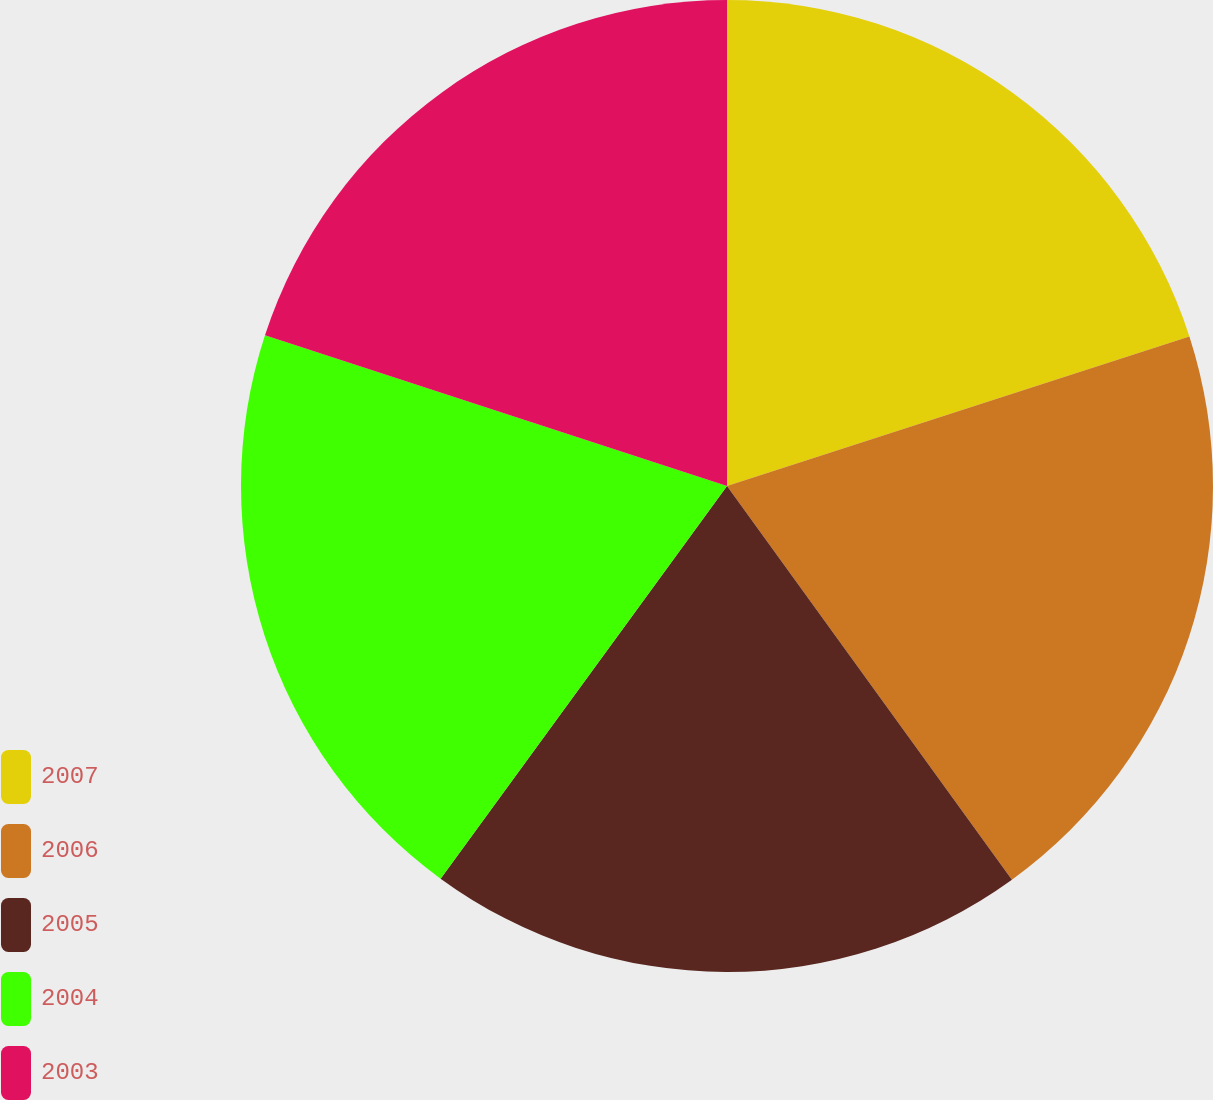<chart> <loc_0><loc_0><loc_500><loc_500><pie_chart><fcel>2007<fcel>2006<fcel>2005<fcel>2004<fcel>2003<nl><fcel>20.02%<fcel>20.01%<fcel>20.0%<fcel>19.99%<fcel>19.98%<nl></chart> 